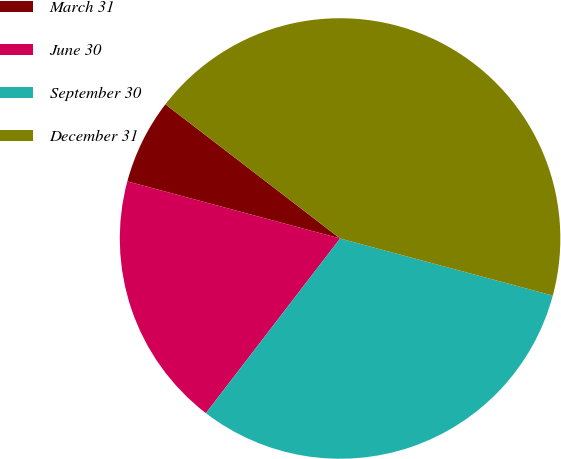Convert chart. <chart><loc_0><loc_0><loc_500><loc_500><pie_chart><fcel>March 31<fcel>June 30<fcel>September 30<fcel>December 31<nl><fcel>6.25%<fcel>18.75%<fcel>31.25%<fcel>43.75%<nl></chart> 